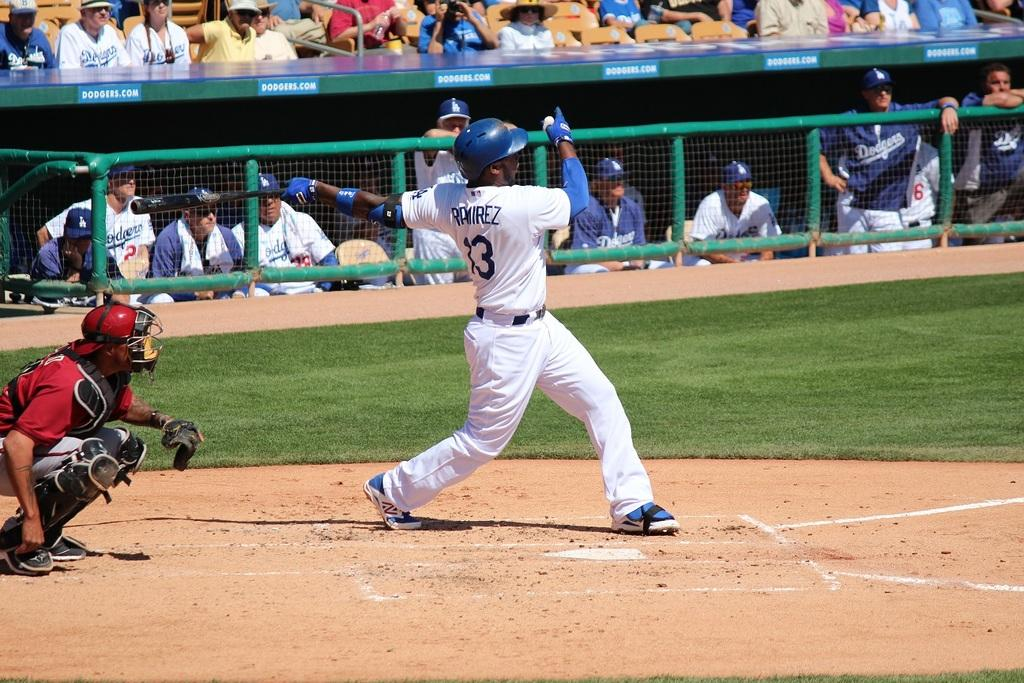<image>
Describe the image concisely. A baseball game is underway and Ramirez is up to bat. 